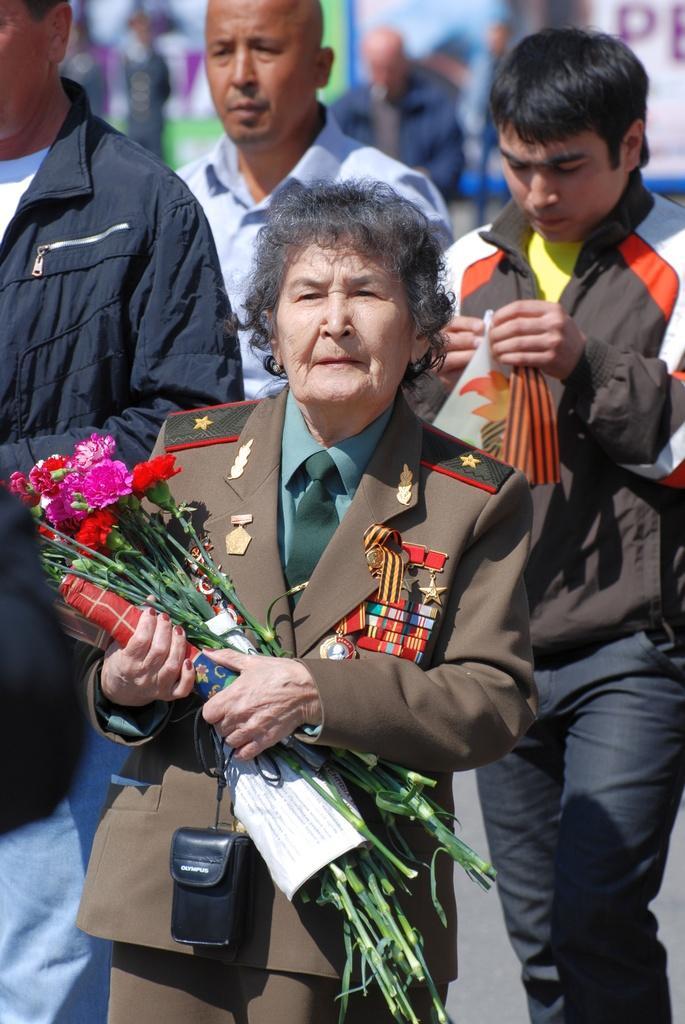Could you give a brief overview of what you see in this image? In the foreground of this image, there is a woman in brown colored suit and holding flowers in her hand. In the background, there are three men walking on the ground and where one is holding a cloth in his hand and in the background we can see few persons. 